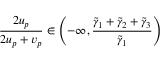<formula> <loc_0><loc_0><loc_500><loc_500>\frac { 2 u _ { p } } { 2 u _ { p } + v _ { p } } \in \left ( - \infty , \frac { \tilde { \gamma } _ { 1 } + \tilde { \gamma } _ { 2 } + \tilde { \gamma } _ { 3 } } { \tilde { \gamma } _ { 1 } } \right )</formula> 